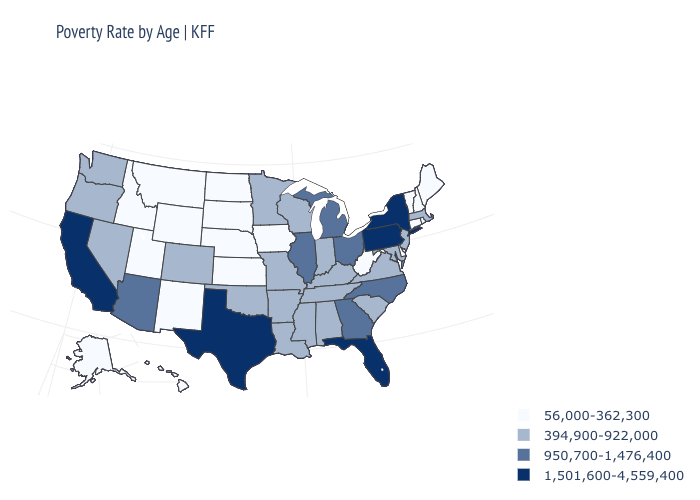What is the value of Pennsylvania?
Keep it brief. 1,501,600-4,559,400. What is the value of California?
Be succinct. 1,501,600-4,559,400. Name the states that have a value in the range 950,700-1,476,400?
Short answer required. Arizona, Georgia, Illinois, Michigan, North Carolina, Ohio. What is the value of Indiana?
Quick response, please. 394,900-922,000. Among the states that border Maryland , which have the highest value?
Write a very short answer. Pennsylvania. What is the value of Connecticut?
Quick response, please. 56,000-362,300. What is the highest value in the Northeast ?
Answer briefly. 1,501,600-4,559,400. What is the value of Maine?
Give a very brief answer. 56,000-362,300. What is the highest value in the South ?
Short answer required. 1,501,600-4,559,400. Which states have the lowest value in the USA?
Keep it brief. Alaska, Connecticut, Delaware, Hawaii, Idaho, Iowa, Kansas, Maine, Montana, Nebraska, New Hampshire, New Mexico, North Dakota, Rhode Island, South Dakota, Utah, Vermont, West Virginia, Wyoming. What is the value of Utah?
Give a very brief answer. 56,000-362,300. Among the states that border Kentucky , does West Virginia have the lowest value?
Answer briefly. Yes. Which states have the highest value in the USA?
Give a very brief answer. California, Florida, New York, Pennsylvania, Texas. Among the states that border Arkansas , does Texas have the highest value?
Write a very short answer. Yes. Does Kansas have the same value as Mississippi?
Be succinct. No. 